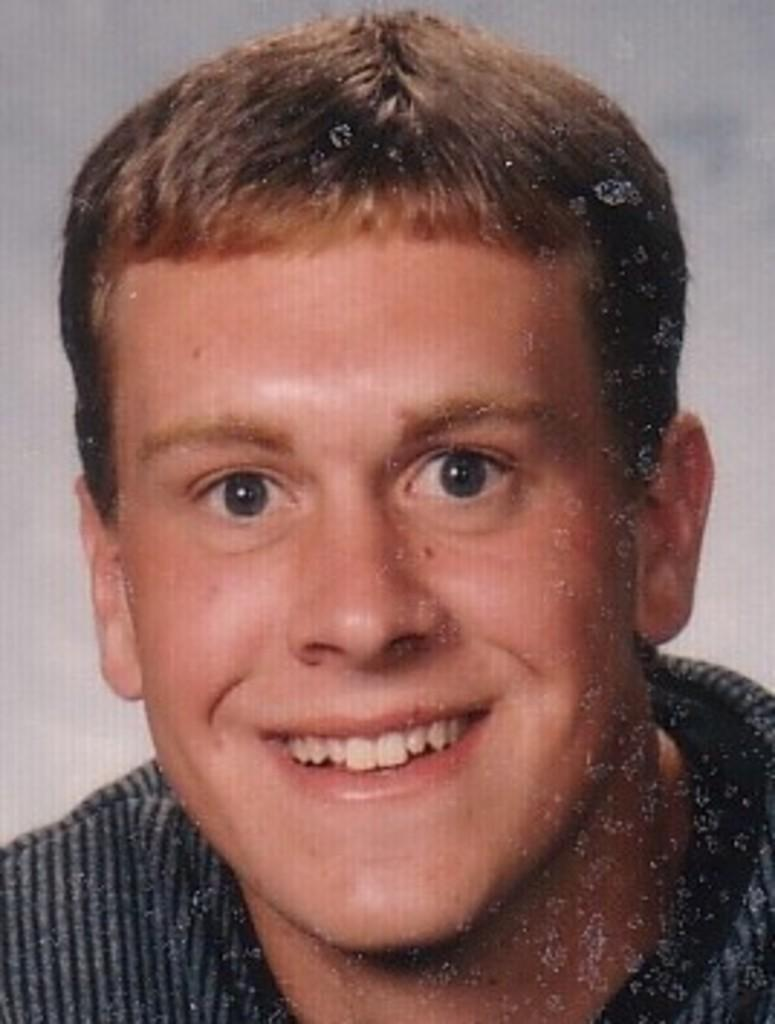What is present in the image? There is a person in the image. How is the person's expression in the image? The person is smiling. What type of sink is visible in the image? There is no sink present in the image. How low is the person sitting in the image? The person is not sitting in the image, and there is no indication of their height or position. 